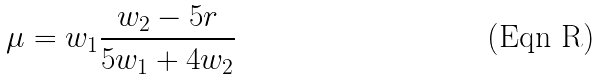<formula> <loc_0><loc_0><loc_500><loc_500>\mu = w _ { 1 } \frac { w _ { 2 } - 5 r } { 5 w _ { 1 } + 4 w _ { 2 } }</formula> 